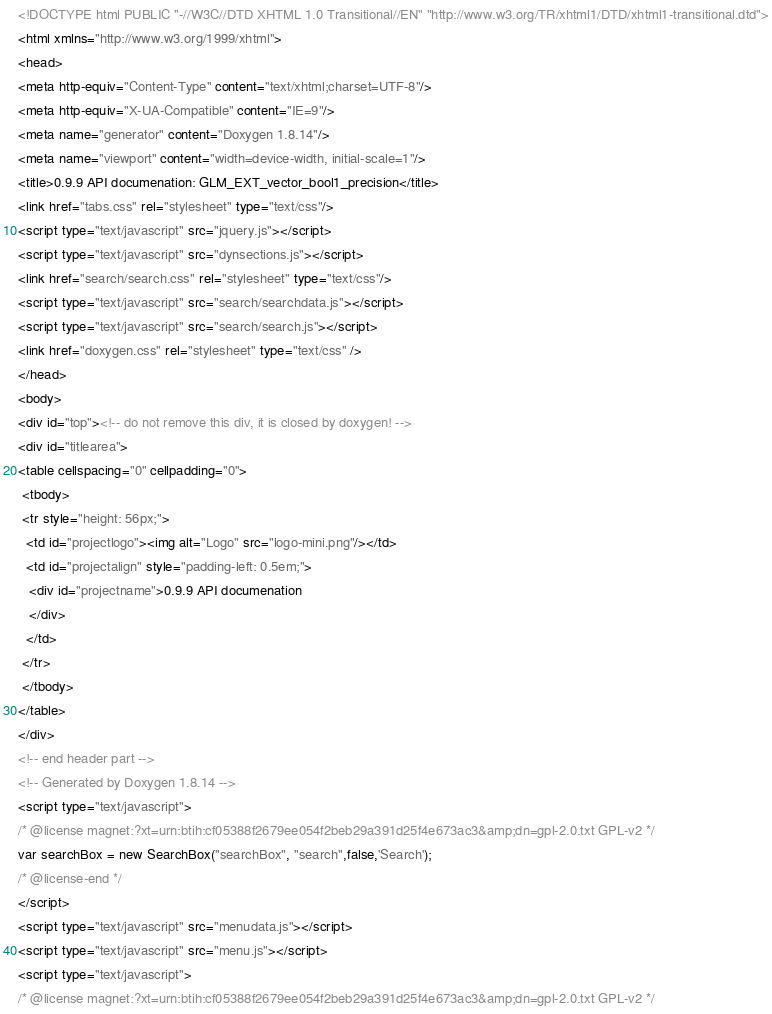<code> <loc_0><loc_0><loc_500><loc_500><_HTML_><!DOCTYPE html PUBLIC "-//W3C//DTD XHTML 1.0 Transitional//EN" "http://www.w3.org/TR/xhtml1/DTD/xhtml1-transitional.dtd">
<html xmlns="http://www.w3.org/1999/xhtml">
<head>
<meta http-equiv="Content-Type" content="text/xhtml;charset=UTF-8"/>
<meta http-equiv="X-UA-Compatible" content="IE=9"/>
<meta name="generator" content="Doxygen 1.8.14"/>
<meta name="viewport" content="width=device-width, initial-scale=1"/>
<title>0.9.9 API documenation: GLM_EXT_vector_bool1_precision</title>
<link href="tabs.css" rel="stylesheet" type="text/css"/>
<script type="text/javascript" src="jquery.js"></script>
<script type="text/javascript" src="dynsections.js"></script>
<link href="search/search.css" rel="stylesheet" type="text/css"/>
<script type="text/javascript" src="search/searchdata.js"></script>
<script type="text/javascript" src="search/search.js"></script>
<link href="doxygen.css" rel="stylesheet" type="text/css" />
</head>
<body>
<div id="top"><!-- do not remove this div, it is closed by doxygen! -->
<div id="titlearea">
<table cellspacing="0" cellpadding="0">
 <tbody>
 <tr style="height: 56px;">
  <td id="projectlogo"><img alt="Logo" src="logo-mini.png"/></td>
  <td id="projectalign" style="padding-left: 0.5em;">
   <div id="projectname">0.9.9 API documenation
   </div>
  </td>
 </tr>
 </tbody>
</table>
</div>
<!-- end header part -->
<!-- Generated by Doxygen 1.8.14 -->
<script type="text/javascript">
/* @license magnet:?xt=urn:btih:cf05388f2679ee054f2beb29a391d25f4e673ac3&amp;dn=gpl-2.0.txt GPL-v2 */
var searchBox = new SearchBox("searchBox", "search",false,'Search');
/* @license-end */
</script>
<script type="text/javascript" src="menudata.js"></script>
<script type="text/javascript" src="menu.js"></script>
<script type="text/javascript">
/* @license magnet:?xt=urn:btih:cf05388f2679ee054f2beb29a391d25f4e673ac3&amp;dn=gpl-2.0.txt GPL-v2 */</code> 